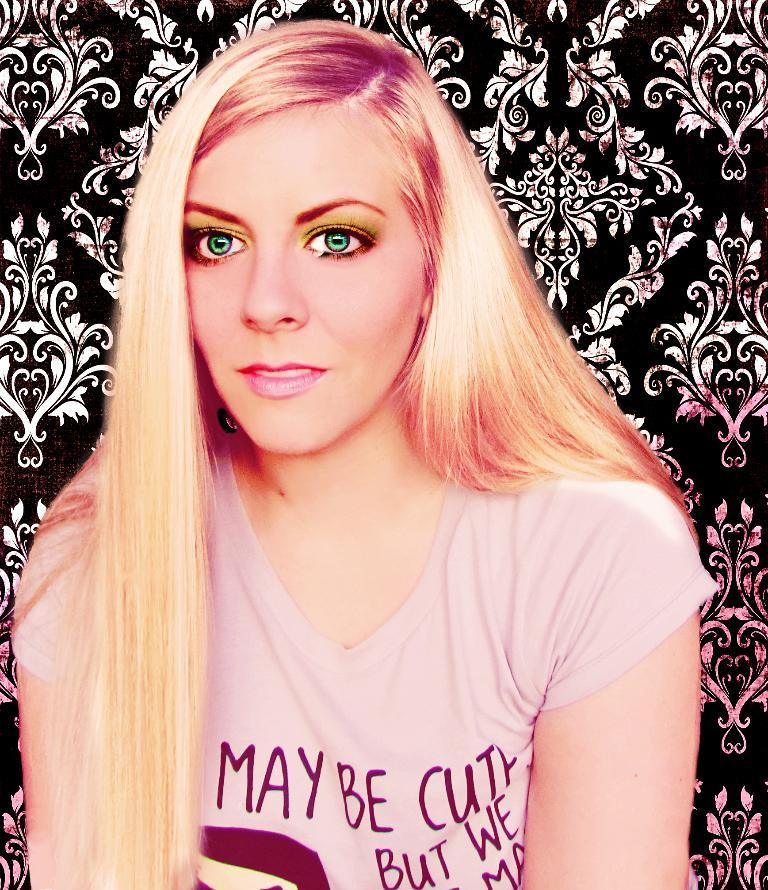What is the main subject of the image? The main subject of the image is a woman. What can be seen in the background of the image? There is a wallpaper in the background of the image. What type of kite is the woman flying in the image? There is no kite present in the image; the woman is the main subject. Can you tell me how many cats are visible in the image? There are no cats visible in the image; the main subject is a woman, and the background features wallpaper. 